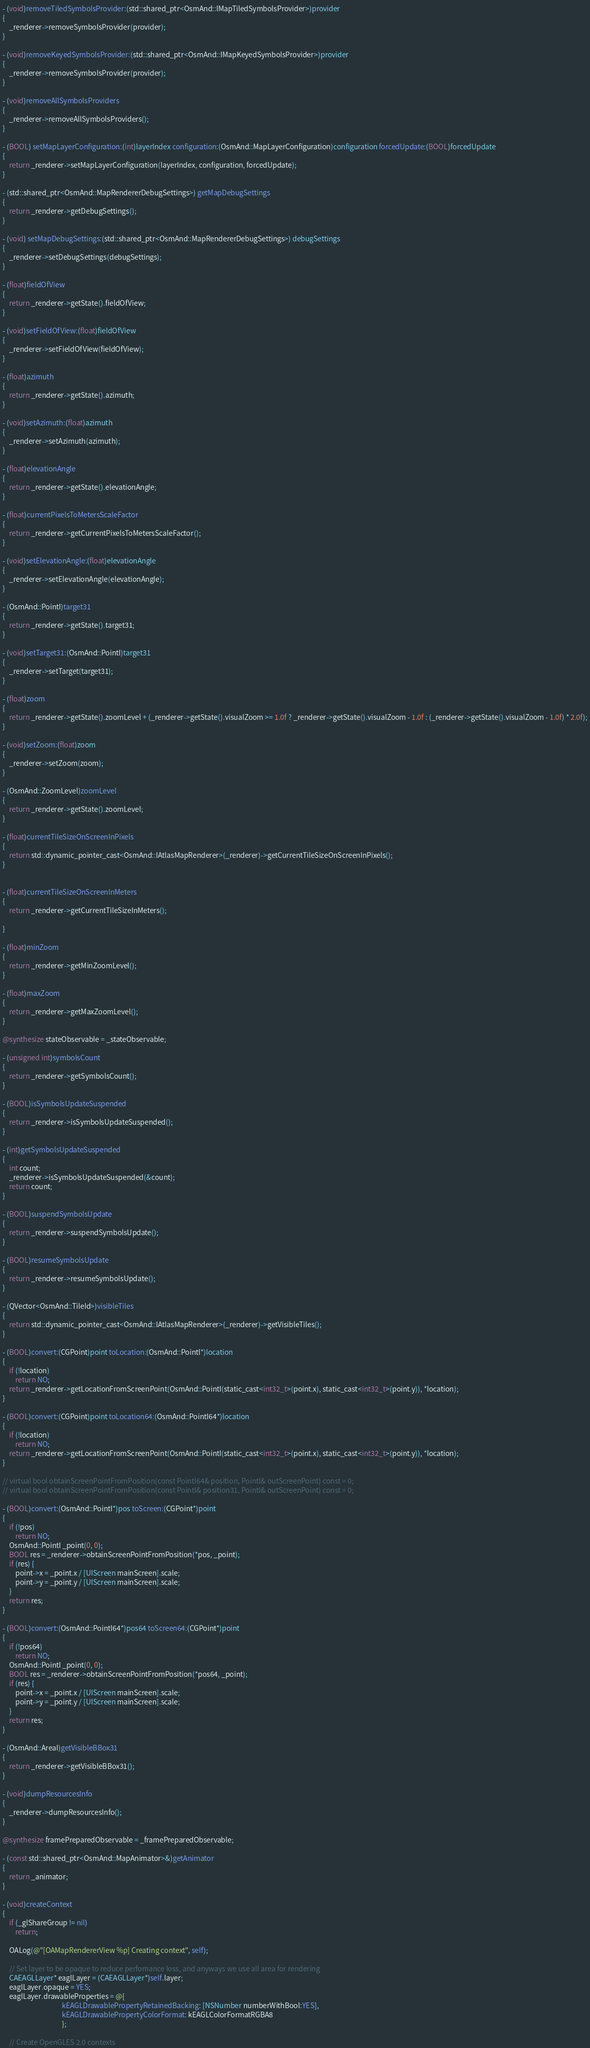Convert code to text. <code><loc_0><loc_0><loc_500><loc_500><_ObjectiveC_>- (void)removeTiledSymbolsProvider:(std::shared_ptr<OsmAnd::IMapTiledSymbolsProvider>)provider
{
    _renderer->removeSymbolsProvider(provider);
}

- (void)removeKeyedSymbolsProvider:(std::shared_ptr<OsmAnd::IMapKeyedSymbolsProvider>)provider
{
    _renderer->removeSymbolsProvider(provider);
}

- (void)removeAllSymbolsProviders
{
    _renderer->removeAllSymbolsProviders();
}

- (BOOL) setMapLayerConfiguration:(int)layerIndex configuration:(OsmAnd::MapLayerConfiguration)configuration forcedUpdate:(BOOL)forcedUpdate
{
    return _renderer->setMapLayerConfiguration(layerIndex, configuration, forcedUpdate);
}

- (std::shared_ptr<OsmAnd::MapRendererDebugSettings>) getMapDebugSettings
{
    return _renderer->getDebugSettings();
}

- (void) setMapDebugSettings:(std::shared_ptr<OsmAnd::MapRendererDebugSettings>) debugSettings
{
    _renderer->setDebugSettings(debugSettings);
}

- (float)fieldOfView
{
    return _renderer->getState().fieldOfView;
}

- (void)setFieldOfView:(float)fieldOfView
{
    _renderer->setFieldOfView(fieldOfView);
}

- (float)azimuth
{
    return _renderer->getState().azimuth;
}

- (void)setAzimuth:(float)azimuth
{
    _renderer->setAzimuth(azimuth);
}

- (float)elevationAngle
{
    return _renderer->getState().elevationAngle;
}

- (float)currentPixelsToMetersScaleFactor
{
    return _renderer->getCurrentPixelsToMetersScaleFactor();
}

- (void)setElevationAngle:(float)elevationAngle
{
    _renderer->setElevationAngle(elevationAngle);
}

- (OsmAnd::PointI)target31
{
    return _renderer->getState().target31;
}

- (void)setTarget31:(OsmAnd::PointI)target31
{
    _renderer->setTarget(target31);
}

- (float)zoom
{
    return _renderer->getState().zoomLevel + (_renderer->getState().visualZoom >= 1.0f ? _renderer->getState().visualZoom - 1.0f : (_renderer->getState().visualZoom - 1.0f) * 2.0f);
}

- (void)setZoom:(float)zoom
{
    _renderer->setZoom(zoom);
}

- (OsmAnd::ZoomLevel)zoomLevel
{
    return _renderer->getState().zoomLevel;
}

- (float)currentTileSizeOnScreenInPixels
{
    return std::dynamic_pointer_cast<OsmAnd::IAtlasMapRenderer>(_renderer)->getCurrentTileSizeOnScreenInPixels();
}


- (float)currentTileSizeOnScreenInMeters
{
    return _renderer->getCurrentTileSizeInMeters();
    
}

- (float)minZoom
{
    return _renderer->getMinZoomLevel();
}

- (float)maxZoom
{
    return _renderer->getMaxZoomLevel();
}

@synthesize stateObservable = _stateObservable;

- (unsigned int)symbolsCount
{
    return _renderer->getSymbolsCount();
}

- (BOOL)isSymbolsUpdateSuspended
{
    return _renderer->isSymbolsUpdateSuspended();
}

- (int)getSymbolsUpdateSuspended
{
    int count;
    _renderer->isSymbolsUpdateSuspended(&count);
    return count;
}

- (BOOL)suspendSymbolsUpdate
{
    return _renderer->suspendSymbolsUpdate();
}

- (BOOL)resumeSymbolsUpdate
{
    return _renderer->resumeSymbolsUpdate();
}

- (QVector<OsmAnd::TileId>)visibleTiles
{
    return std::dynamic_pointer_cast<OsmAnd::IAtlasMapRenderer>(_renderer)->getVisibleTiles();
}

- (BOOL)convert:(CGPoint)point toLocation:(OsmAnd::PointI*)location
{
    if (!location)
        return NO;
    return _renderer->getLocationFromScreenPoint(OsmAnd::PointI(static_cast<int32_t>(point.x), static_cast<int32_t>(point.y)), *location);
}

- (BOOL)convert:(CGPoint)point toLocation64:(OsmAnd::PointI64*)location
{
    if (!location)
        return NO;
    return _renderer->getLocationFromScreenPoint(OsmAnd::PointI(static_cast<int32_t>(point.x), static_cast<int32_t>(point.y)), *location);
}

// virtual bool obtainScreenPointFromPosition(const PointI64& position, PointI& outScreenPoint) const = 0;
// virtual bool obtainScreenPointFromPosition(const PointI& position31, PointI& outScreenPoint) const = 0;

- (BOOL)convert:(OsmAnd::PointI*)pos toScreen:(CGPoint*)point
{
    if (!pos)
        return NO;
    OsmAnd::PointI _point(0, 0);
    BOOL res = _renderer->obtainScreenPointFromPosition(*pos, _point);
    if (res) {
        point->x = _point.x / [UIScreen mainScreen].scale;
        point->y = _point.y / [UIScreen mainScreen].scale;
    }
    return res;
}

- (BOOL)convert:(OsmAnd::PointI64*)pos64 toScreen64:(CGPoint*)point
{
    if (!pos64)
        return NO;
    OsmAnd::PointI _point(0, 0);
    BOOL res = _renderer->obtainScreenPointFromPosition(*pos64, _point);
    if (res) {
        point->x = _point.x / [UIScreen mainScreen].scale;
        point->y = _point.y / [UIScreen mainScreen].scale;
    }
    return res;
}

- (OsmAnd::AreaI)getVisibleBBox31
{
    return _renderer->getVisibleBBox31();
}

- (void)dumpResourcesInfo
{
    _renderer->dumpResourcesInfo();
}

@synthesize framePreparedObservable = _framePreparedObservable;

- (const std::shared_ptr<OsmAnd::MapAnimator>&)getAnimator
{
    return _animator;
}

- (void)createContext
{
    if (_glShareGroup != nil)
        return;

    OALog(@"[OAMapRendererView %p] Creating context", self);

    // Set layer to be opaque to reduce perfomance loss, and anyways we use all area for rendering
    CAEAGLLayer* eaglLayer = (CAEAGLLayer*)self.layer;
    eaglLayer.opaque = YES;
    eaglLayer.drawableProperties = @{
                                     kEAGLDrawablePropertyRetainedBacking: [NSNumber numberWithBool:YES],
                                     kEAGLDrawablePropertyColorFormat: kEAGLColorFormatRGBA8
                                     };
    
    // Create OpenGLES 2.0 contexts</code> 